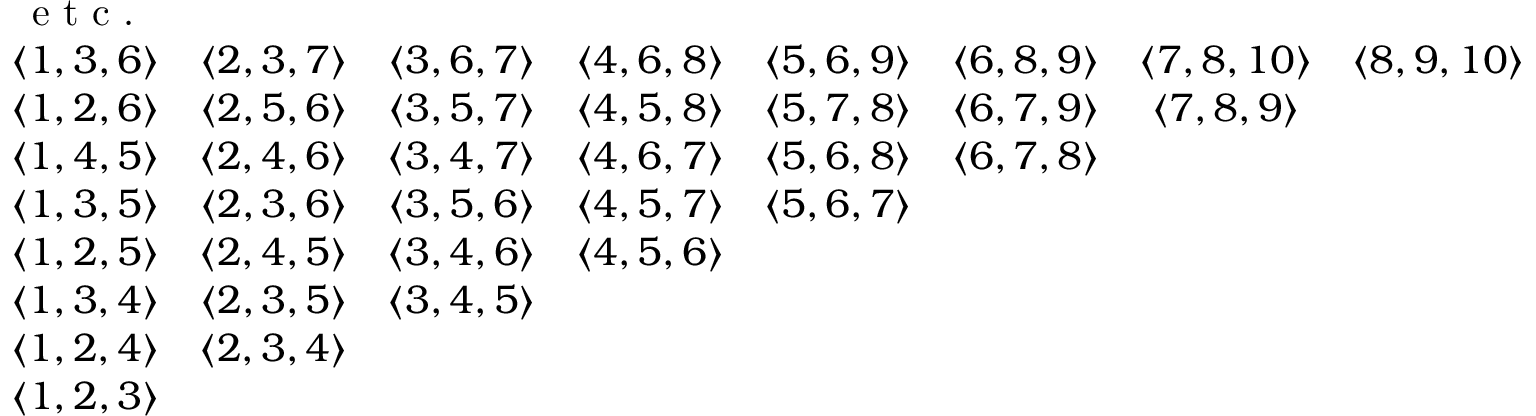<formula> <loc_0><loc_0><loc_500><loc_500>\begin{array} { c c c c c c c c c } { e t c . } & & & & & & & & \\ { \langle 1 , 3 , 6 \rangle } & { \langle 2 , 3 , 7 \rangle } & { \langle 3 , 6 , 7 \rangle } & { \langle 4 , 6 , 8 \rangle } & { \langle 5 , 6 , 9 \rangle } & { \langle 6 , 8 , 9 \rangle } & { \langle 7 , 8 , 1 0 \rangle } & { \langle 8 , 9 , 1 0 \rangle } & \\ { \langle 1 , 2 , 6 \rangle } & { \langle 2 , 5 , 6 \rangle } & { \langle 3 , 5 , 7 \rangle } & { \langle 4 , 5 , 8 \rangle } & { \langle 5 , 7 , 8 \rangle } & { \langle 6 , 7 , 9 \rangle } & { \langle 7 , 8 , 9 \rangle } & & \\ { \langle 1 , 4 , 5 \rangle } & { \langle 2 , 4 , 6 \rangle } & { \langle 3 , 4 , 7 \rangle } & { \langle 4 , 6 , 7 \rangle } & { \langle 5 , 6 , 8 \rangle } & { \langle 6 , 7 , 8 \rangle } & & & \\ { \langle 1 , 3 , 5 \rangle } & { \langle 2 , 3 , 6 \rangle } & { \langle 3 , 5 , 6 \rangle } & { \langle 4 , 5 , 7 \rangle } & { \langle 5 , 6 , 7 \rangle } & & & & \\ { \langle 1 , 2 , 5 \rangle } & { \langle 2 , 4 , 5 \rangle } & { \langle 3 , 4 , 6 \rangle } & { \langle 4 , 5 , 6 \rangle } & & & & & \\ { \langle 1 , 3 , 4 \rangle } & { \langle 2 , 3 , 5 \rangle } & { \langle 3 , 4 , 5 \rangle } & & & & & & \\ { \langle 1 , 2 , 4 \rangle } & { \langle 2 , 3 , 4 \rangle } & & & & & & & \\ { \langle 1 , 2 , 3 \rangle } & & & & & & & & \end{array}</formula> 